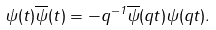<formula> <loc_0><loc_0><loc_500><loc_500>\psi ( t ) \overline { \psi } ( t ) = - q ^ { - 1 } \overline { \psi } ( q t ) \psi ( q t ) .</formula> 